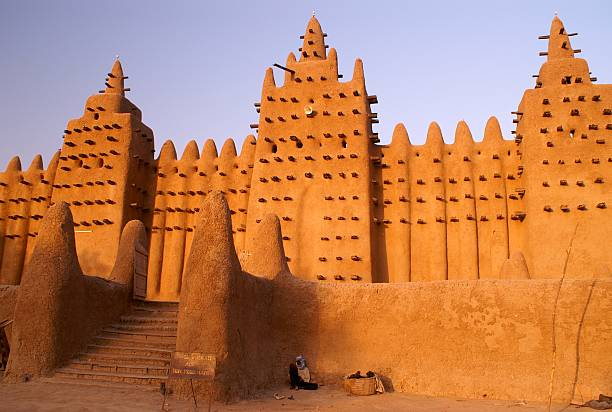A descriptive prompt about the cultural rituals associated with the mosque. The cultural rituals associated with the Great Mosque of Djenné are deeply ingrained in the community’s way of life. Chief among these is the annual re-plastering festival, known as the 'Crepissage de la Grand Mosquée.' This tradition, spanning back generations, sees the entire community coming together to renew the mosque's mud coating. Men collect and mix the mud, while women and children carry water from the river, each individual playing a vital role in the process. Drummers and singers provide a festive backdrop, turning the labor into a joyful celebration. The mosque also plays a central role in the observance of Islamic holy days, with prayers, sermons, and communal meals reinforcing its standing as a spiritual and social cornerstone of Djenné. 